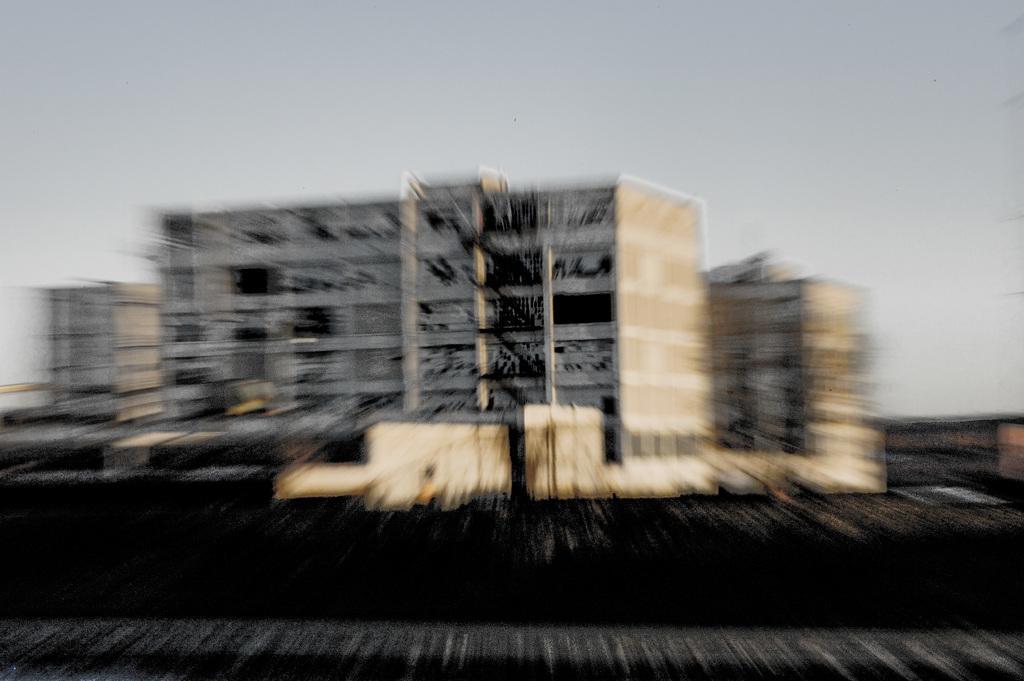Could you give a brief overview of what you see in this image? This is a blur image. In this image we can see buildings and sky in the background. 